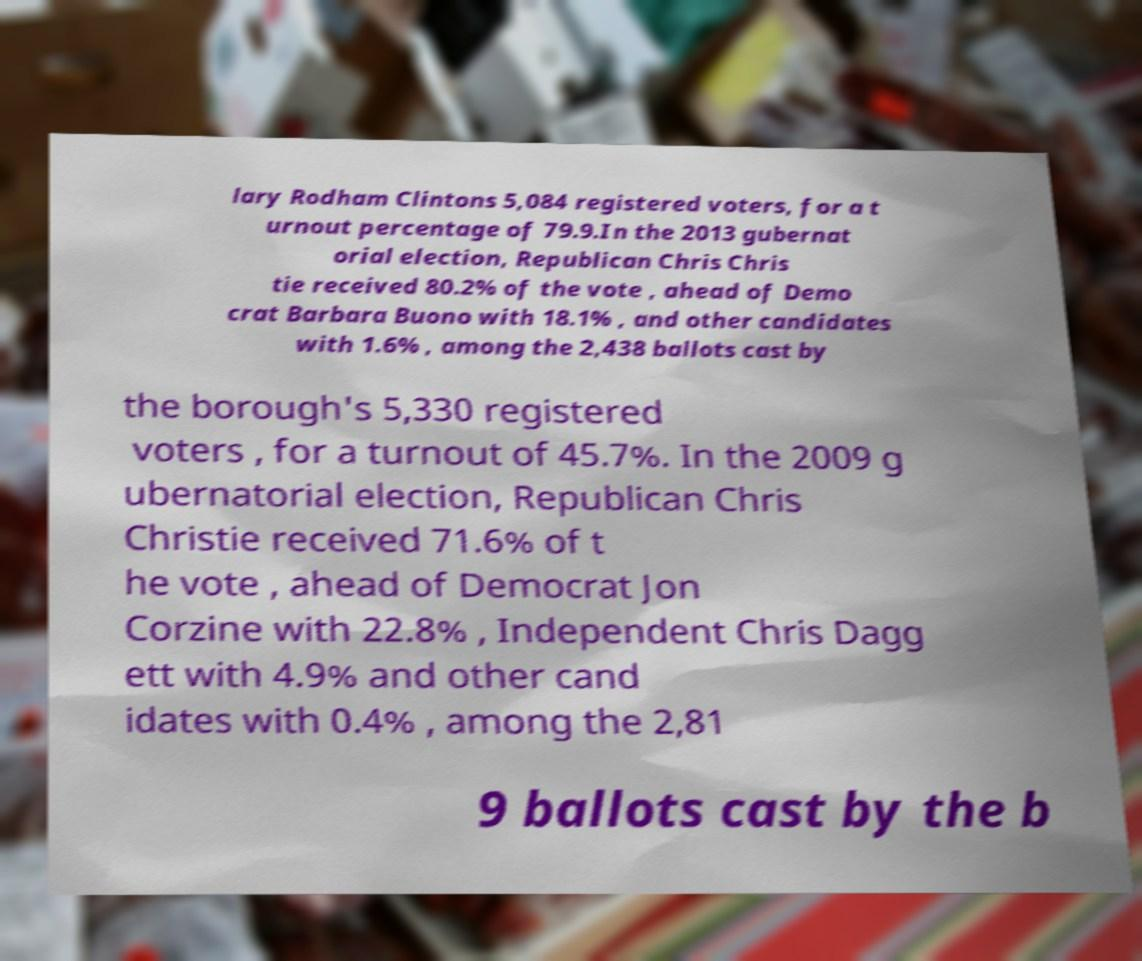Can you accurately transcribe the text from the provided image for me? lary Rodham Clintons 5,084 registered voters, for a t urnout percentage of 79.9.In the 2013 gubernat orial election, Republican Chris Chris tie received 80.2% of the vote , ahead of Demo crat Barbara Buono with 18.1% , and other candidates with 1.6% , among the 2,438 ballots cast by the borough's 5,330 registered voters , for a turnout of 45.7%. In the 2009 g ubernatorial election, Republican Chris Christie received 71.6% of t he vote , ahead of Democrat Jon Corzine with 22.8% , Independent Chris Dagg ett with 4.9% and other cand idates with 0.4% , among the 2,81 9 ballots cast by the b 